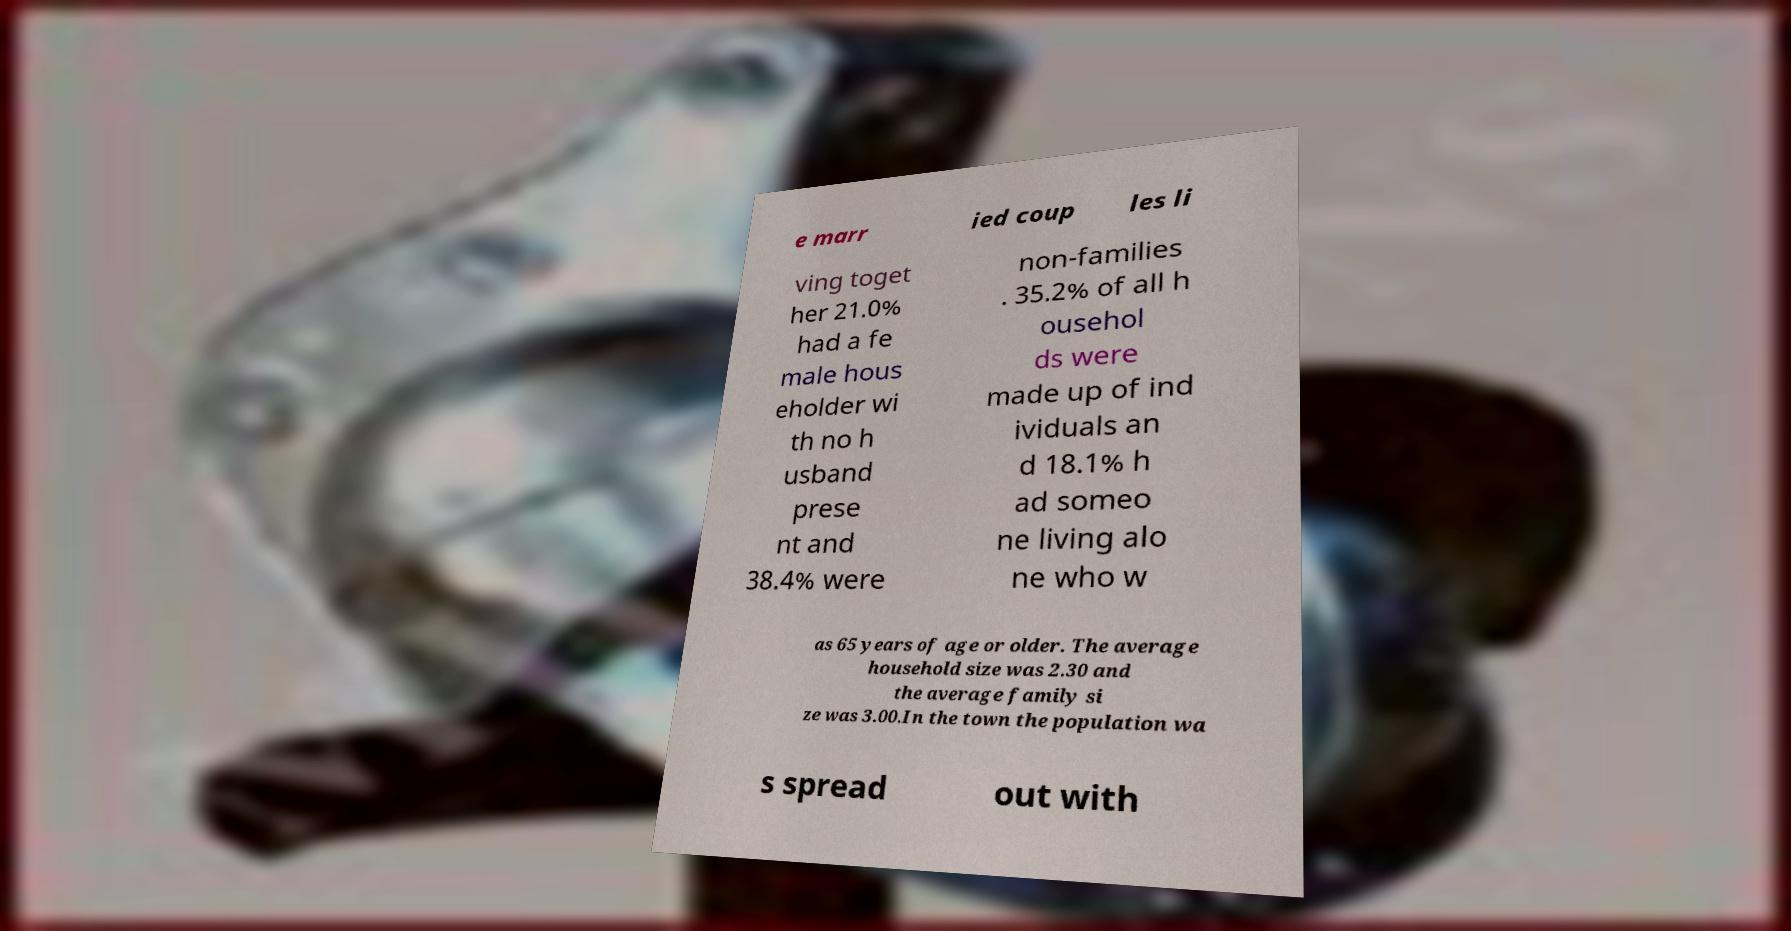I need the written content from this picture converted into text. Can you do that? e marr ied coup les li ving toget her 21.0% had a fe male hous eholder wi th no h usband prese nt and 38.4% were non-families . 35.2% of all h ousehol ds were made up of ind ividuals an d 18.1% h ad someo ne living alo ne who w as 65 years of age or older. The average household size was 2.30 and the average family si ze was 3.00.In the town the population wa s spread out with 